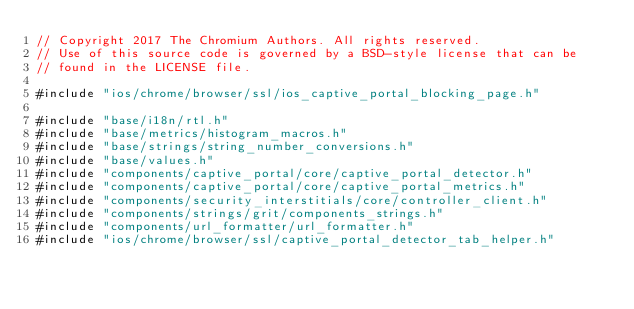Convert code to text. <code><loc_0><loc_0><loc_500><loc_500><_ObjectiveC_>// Copyright 2017 The Chromium Authors. All rights reserved.
// Use of this source code is governed by a BSD-style license that can be
// found in the LICENSE file.

#include "ios/chrome/browser/ssl/ios_captive_portal_blocking_page.h"

#include "base/i18n/rtl.h"
#include "base/metrics/histogram_macros.h"
#include "base/strings/string_number_conversions.h"
#include "base/values.h"
#include "components/captive_portal/core/captive_portal_detector.h"
#include "components/captive_portal/core/captive_portal_metrics.h"
#include "components/security_interstitials/core/controller_client.h"
#include "components/strings/grit/components_strings.h"
#include "components/url_formatter/url_formatter.h"
#include "ios/chrome/browser/ssl/captive_portal_detector_tab_helper.h"</code> 